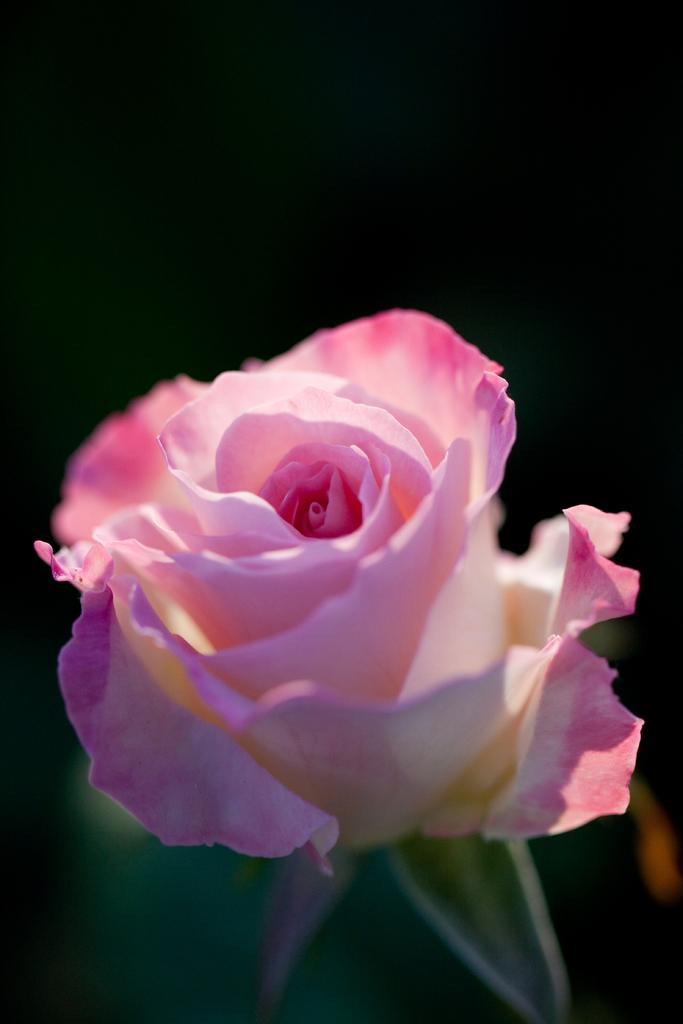What type of flower is in the image? There is a pink flower in the image. What can be seen in the background of the image? The background of the image is dark. How does the flower stop the operation in the image? The flower does not stop any operation in the image; it is a static image of a flower. 